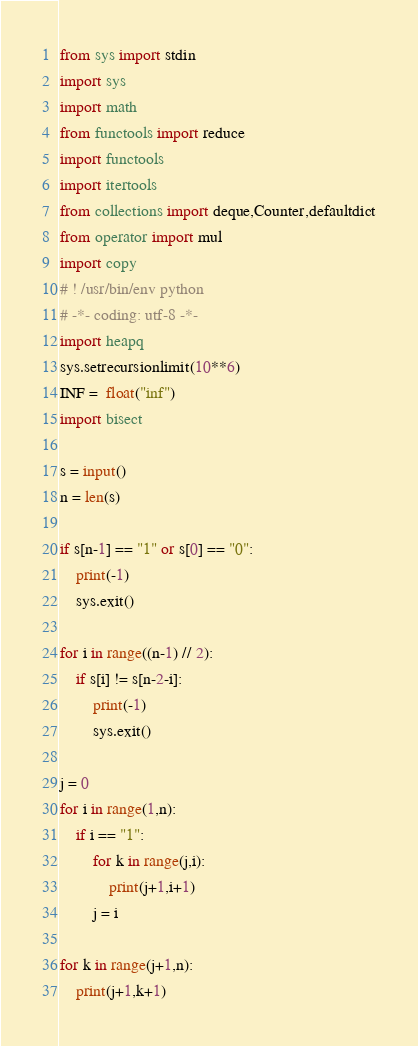<code> <loc_0><loc_0><loc_500><loc_500><_Python_>from sys import stdin
import sys
import math
from functools import reduce
import functools
import itertools
from collections import deque,Counter,defaultdict
from operator import mul
import copy
# ! /usr/bin/env python
# -*- coding: utf-8 -*-
import heapq
sys.setrecursionlimit(10**6)
INF =  float("inf")
import bisect

s = input()
n = len(s)

if s[n-1] == "1" or s[0] == "0":
    print(-1)
    sys.exit()

for i in range((n-1) // 2):
    if s[i] != s[n-2-i]:
        print(-1)
        sys.exit()

j = 0
for i in range(1,n):
    if i == "1":
        for k in range(j,i):
            print(j+1,i+1)
        j = i

for k in range(j+1,n):
    print(j+1,k+1)



</code> 